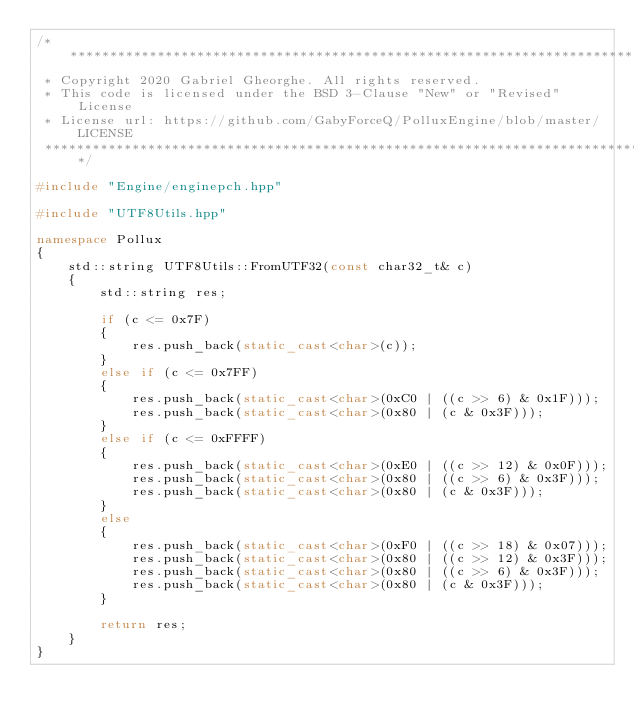Convert code to text. <code><loc_0><loc_0><loc_500><loc_500><_C++_>/*****************************************************************************************************************************
 * Copyright 2020 Gabriel Gheorghe. All rights reserved.
 * This code is licensed under the BSD 3-Clause "New" or "Revised" License
 * License url: https://github.com/GabyForceQ/PolluxEngine/blob/master/LICENSE
 *****************************************************************************************************************************/

#include "Engine/enginepch.hpp"

#include "UTF8Utils.hpp"

namespace Pollux
{
	std::string UTF8Utils::FromUTF32(const char32_t& c)
	{
        std::string res;

        if (c <= 0x7F)
        {
            res.push_back(static_cast<char>(c));
        }
        else if (c <= 0x7FF)
        {
            res.push_back(static_cast<char>(0xC0 | ((c >> 6) & 0x1F)));
            res.push_back(static_cast<char>(0x80 | (c & 0x3F)));
        }
        else if (c <= 0xFFFF)
        {
            res.push_back(static_cast<char>(0xE0 | ((c >> 12) & 0x0F)));
            res.push_back(static_cast<char>(0x80 | ((c >> 6) & 0x3F)));
            res.push_back(static_cast<char>(0x80 | (c & 0x3F)));
        }
        else
        {
            res.push_back(static_cast<char>(0xF0 | ((c >> 18) & 0x07)));
            res.push_back(static_cast<char>(0x80 | ((c >> 12) & 0x3F)));
            res.push_back(static_cast<char>(0x80 | ((c >> 6) & 0x3F)));
            res.push_back(static_cast<char>(0x80 | (c & 0x3F)));
        }

        return res;
	}
}</code> 